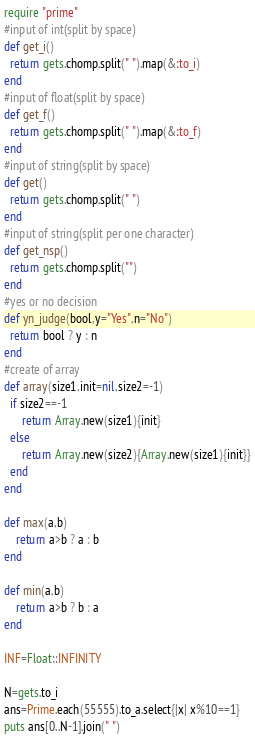<code> <loc_0><loc_0><loc_500><loc_500><_Ruby_>require "prime"
#input of int(split by space)
def get_i()
  return gets.chomp.split(" ").map(&:to_i)
end
#input of float(split by space)
def get_f()
  return gets.chomp.split(" ").map(&:to_f)
end
#input of string(split by space)
def get()
  return gets.chomp.split(" ")
end
#input of string(split per one character)
def get_nsp()
  return gets.chomp.split("")
end
#yes or no decision
def yn_judge(bool,y="Yes",n="No")
  return bool ? y : n 
end
#create of array
def array(size1,init=nil,size2=-1)
  if size2==-1
      return Array.new(size1){init}
  else
      return Array.new(size2){Array.new(size1){init}}
  end
end

def max(a,b)
    return a>b ? a : b
end

def min(a,b)
    return a>b ? b : a
end

INF=Float::INFINITY

N=gets.to_i
ans=Prime.each(55555).to_a.select{|x| x%10==1}
puts ans[0..N-1].join(" ")</code> 